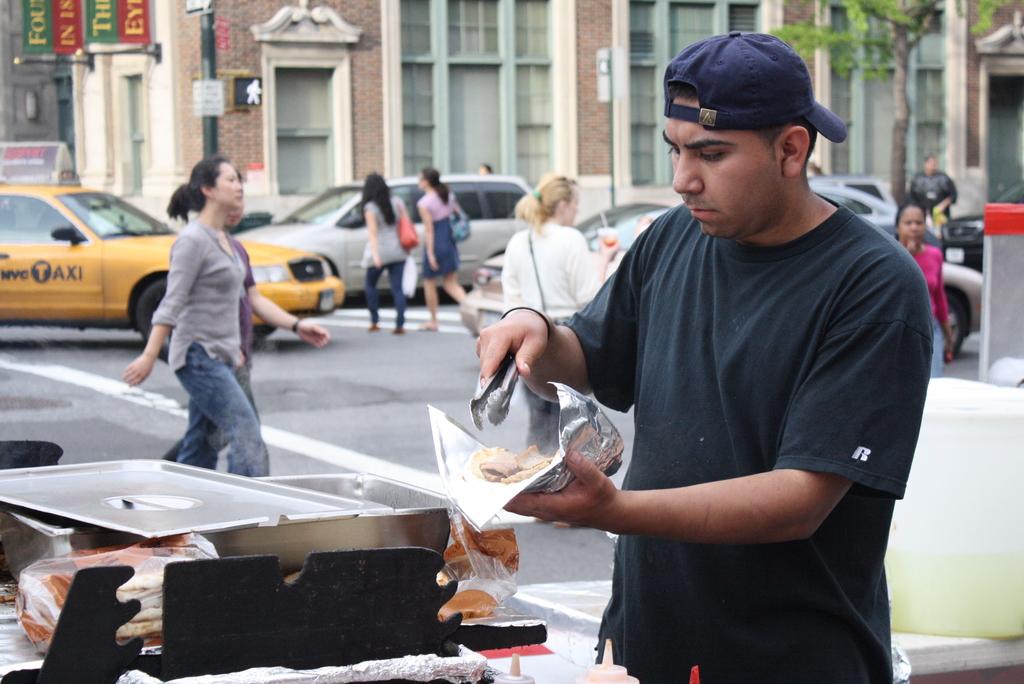What the the yellow car say?
Your answer should be very brief. Taxi. What is the letter that is on the man's sleeve?
Provide a succinct answer. R. 